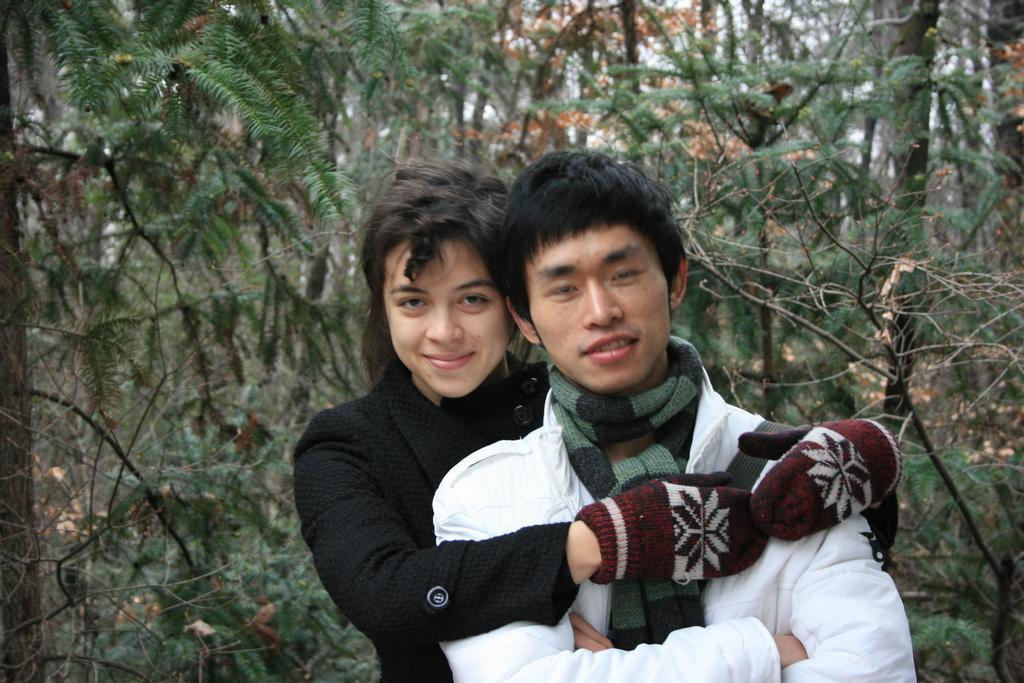In one or two sentences, can you explain what this image depicts? In this picture we can see two people smiling and at the back of them we can see trees. 